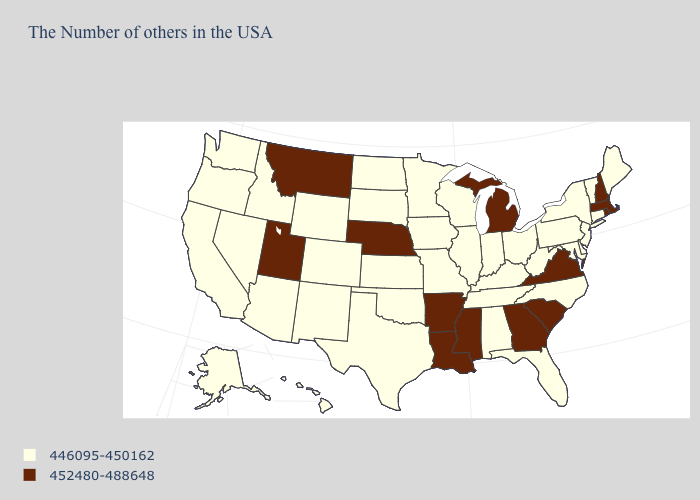Name the states that have a value in the range 446095-450162?
Be succinct. Maine, Vermont, Connecticut, New York, New Jersey, Delaware, Maryland, Pennsylvania, North Carolina, West Virginia, Ohio, Florida, Kentucky, Indiana, Alabama, Tennessee, Wisconsin, Illinois, Missouri, Minnesota, Iowa, Kansas, Oklahoma, Texas, South Dakota, North Dakota, Wyoming, Colorado, New Mexico, Arizona, Idaho, Nevada, California, Washington, Oregon, Alaska, Hawaii. Name the states that have a value in the range 446095-450162?
Quick response, please. Maine, Vermont, Connecticut, New York, New Jersey, Delaware, Maryland, Pennsylvania, North Carolina, West Virginia, Ohio, Florida, Kentucky, Indiana, Alabama, Tennessee, Wisconsin, Illinois, Missouri, Minnesota, Iowa, Kansas, Oklahoma, Texas, South Dakota, North Dakota, Wyoming, Colorado, New Mexico, Arizona, Idaho, Nevada, California, Washington, Oregon, Alaska, Hawaii. Does the first symbol in the legend represent the smallest category?
Quick response, please. Yes. What is the highest value in the West ?
Keep it brief. 452480-488648. What is the value of Indiana?
Answer briefly. 446095-450162. Among the states that border Oklahoma , which have the highest value?
Concise answer only. Arkansas. What is the value of California?
Be succinct. 446095-450162. Does Missouri have the highest value in the USA?
Quick response, please. No. What is the value of Arizona?
Keep it brief. 446095-450162. Among the states that border Virginia , which have the lowest value?
Be succinct. Maryland, North Carolina, West Virginia, Kentucky, Tennessee. Does Georgia have the highest value in the USA?
Be succinct. Yes. Among the states that border Colorado , does Utah have the highest value?
Answer briefly. Yes. Among the states that border Connecticut , which have the lowest value?
Concise answer only. New York. What is the value of New Mexico?
Quick response, please. 446095-450162. Name the states that have a value in the range 446095-450162?
Quick response, please. Maine, Vermont, Connecticut, New York, New Jersey, Delaware, Maryland, Pennsylvania, North Carolina, West Virginia, Ohio, Florida, Kentucky, Indiana, Alabama, Tennessee, Wisconsin, Illinois, Missouri, Minnesota, Iowa, Kansas, Oklahoma, Texas, South Dakota, North Dakota, Wyoming, Colorado, New Mexico, Arizona, Idaho, Nevada, California, Washington, Oregon, Alaska, Hawaii. 